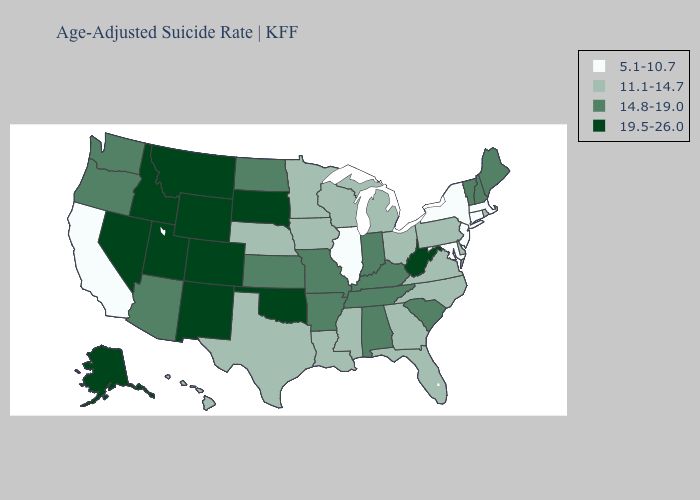Does the map have missing data?
Be succinct. No. Does New Jersey have the lowest value in the Northeast?
Write a very short answer. Yes. Among the states that border California , which have the lowest value?
Concise answer only. Arizona, Oregon. What is the highest value in the MidWest ?
Give a very brief answer. 19.5-26.0. What is the lowest value in the USA?
Give a very brief answer. 5.1-10.7. What is the lowest value in the MidWest?
Keep it brief. 5.1-10.7. What is the value of Florida?
Quick response, please. 11.1-14.7. What is the lowest value in the USA?
Concise answer only. 5.1-10.7. Does Kansas have the highest value in the USA?
Short answer required. No. Which states have the highest value in the USA?
Write a very short answer. Alaska, Colorado, Idaho, Montana, Nevada, New Mexico, Oklahoma, South Dakota, Utah, West Virginia, Wyoming. What is the value of Missouri?
Keep it brief. 14.8-19.0. Name the states that have a value in the range 19.5-26.0?
Concise answer only. Alaska, Colorado, Idaho, Montana, Nevada, New Mexico, Oklahoma, South Dakota, Utah, West Virginia, Wyoming. What is the value of Washington?
Be succinct. 14.8-19.0. What is the value of Tennessee?
Concise answer only. 14.8-19.0. 